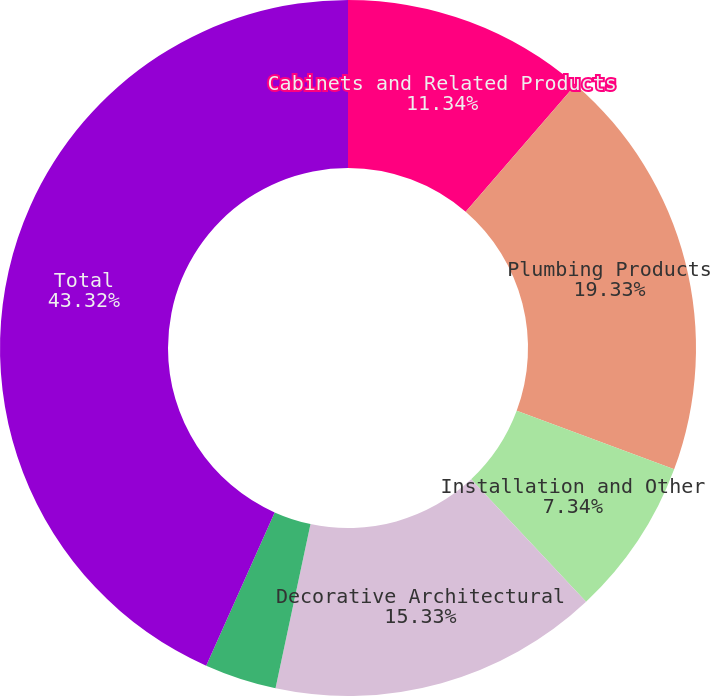Convert chart. <chart><loc_0><loc_0><loc_500><loc_500><pie_chart><fcel>Cabinets and Related Products<fcel>Plumbing Products<fcel>Installation and Other<fcel>Decorative Architectural<fcel>Other Specialty Products<fcel>Total<nl><fcel>11.34%<fcel>19.33%<fcel>7.34%<fcel>15.33%<fcel>3.34%<fcel>43.32%<nl></chart> 